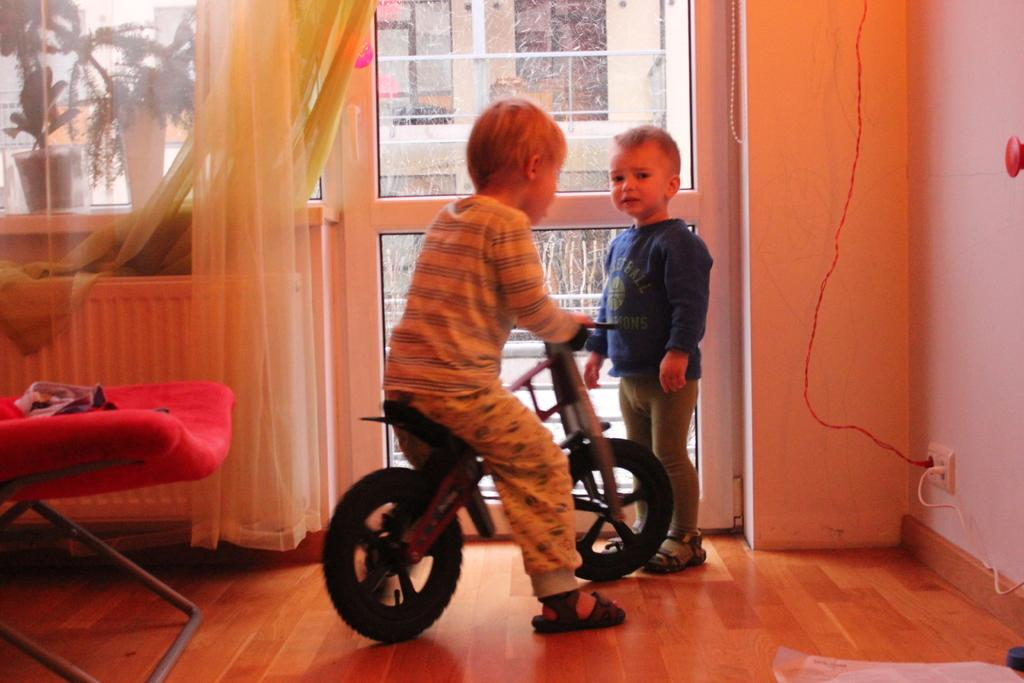What is the main activity depicted in the image? There is a boy riding a bicycle in the image. Are there any other people present in the image? Yes, there is another boy standing beside the bicycle in the image. How many apples are the boys eating in the image? There are no apples present in the image; the boys are focused on the bicycle. What type of disease do the boys have in the image? There is no indication of any disease in the image; the boys appear to be healthy and engaged in an activity. 